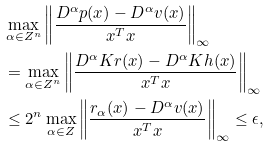<formula> <loc_0><loc_0><loc_500><loc_500>& \max _ { \alpha \in Z ^ { n } } \left \| \frac { D ^ { \alpha } p ( x ) - D ^ { \alpha } v ( x ) } { x ^ { T } x } \right \| _ { \infty } \\ & = \max _ { \alpha \in Z ^ { n } } \left \| \frac { D ^ { \alpha } K r ( x ) - D ^ { \alpha } K h ( x ) } { x ^ { T } x } \right \| _ { \infty } \\ & \leq 2 ^ { n } \max _ { \alpha \in Z } \left \| \frac { r _ { \alpha } ( x ) - D ^ { \alpha } v ( x ) } { x ^ { T } x } \right \| _ { \infty } \leq \epsilon ,</formula> 